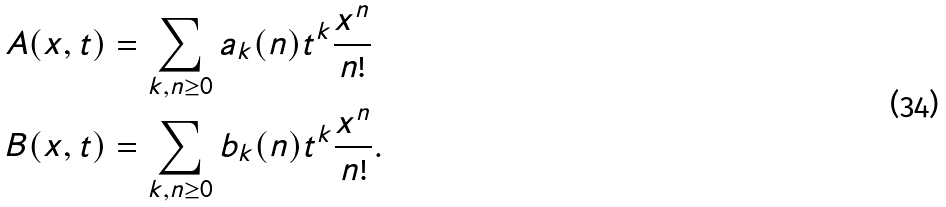Convert formula to latex. <formula><loc_0><loc_0><loc_500><loc_500>A ( x , t ) & = \sum _ { k , n \geq 0 } a _ { k } ( n ) t ^ { k } \frac { x ^ { n } } { n ! } \\ B ( x , t ) & = \sum _ { k , n \geq 0 } b _ { k } ( n ) t ^ { k } \frac { x ^ { n } } { n ! } .</formula> 